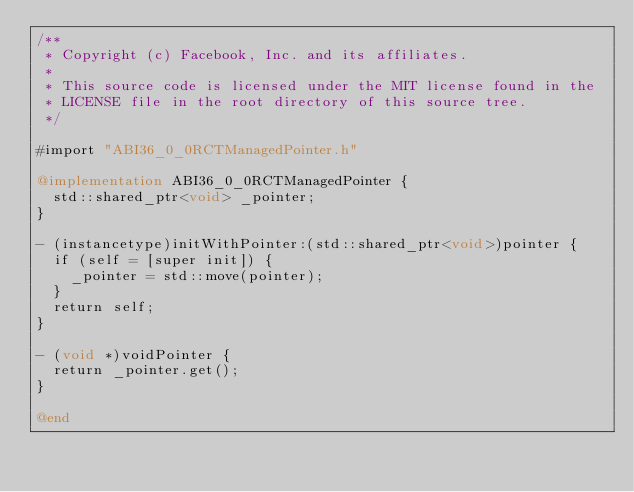<code> <loc_0><loc_0><loc_500><loc_500><_ObjectiveC_>/**
 * Copyright (c) Facebook, Inc. and its affiliates.
 *
 * This source code is licensed under the MIT license found in the
 * LICENSE file in the root directory of this source tree.
 */

#import "ABI36_0_0RCTManagedPointer.h"

@implementation ABI36_0_0RCTManagedPointer {
  std::shared_ptr<void> _pointer;
}

- (instancetype)initWithPointer:(std::shared_ptr<void>)pointer {
  if (self = [super init]) {
    _pointer = std::move(pointer);
  }
  return self;
}

- (void *)voidPointer {
  return _pointer.get();
}

@end
</code> 